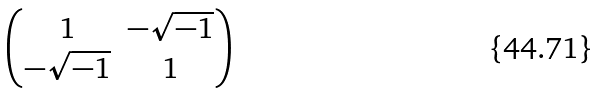Convert formula to latex. <formula><loc_0><loc_0><loc_500><loc_500>\begin{pmatrix} 1 & - \sqrt { - 1 } \\ - \sqrt { - 1 } & 1 \end{pmatrix}</formula> 